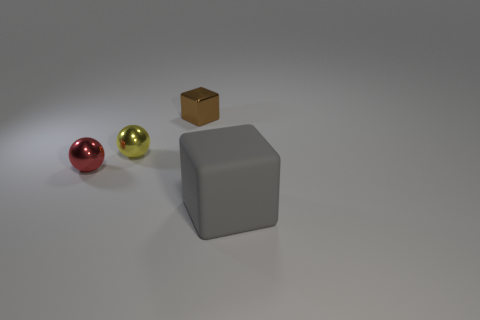Add 3 small blue balls. How many objects exist? 7 Add 1 small cubes. How many small cubes are left? 2 Add 2 small metal spheres. How many small metal spheres exist? 4 Subtract 0 cyan cylinders. How many objects are left? 4 Subtract all small blocks. Subtract all blocks. How many objects are left? 1 